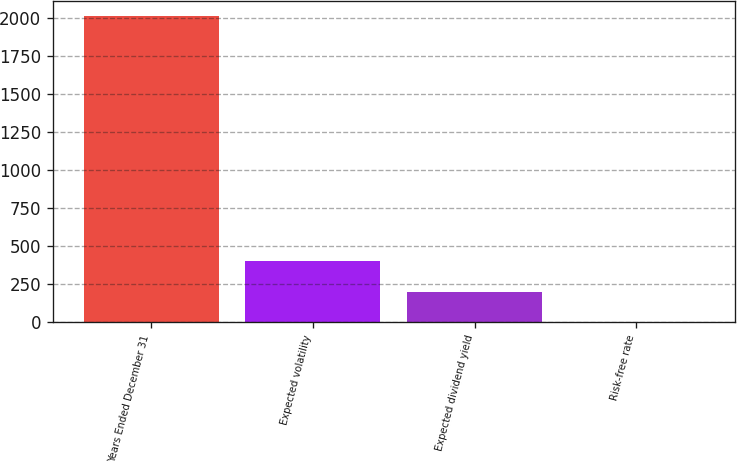<chart> <loc_0><loc_0><loc_500><loc_500><bar_chart><fcel>Years Ended December 31<fcel>Expected volatility<fcel>Expected dividend yield<fcel>Risk-free rate<nl><fcel>2014<fcel>403.44<fcel>202.12<fcel>0.8<nl></chart> 